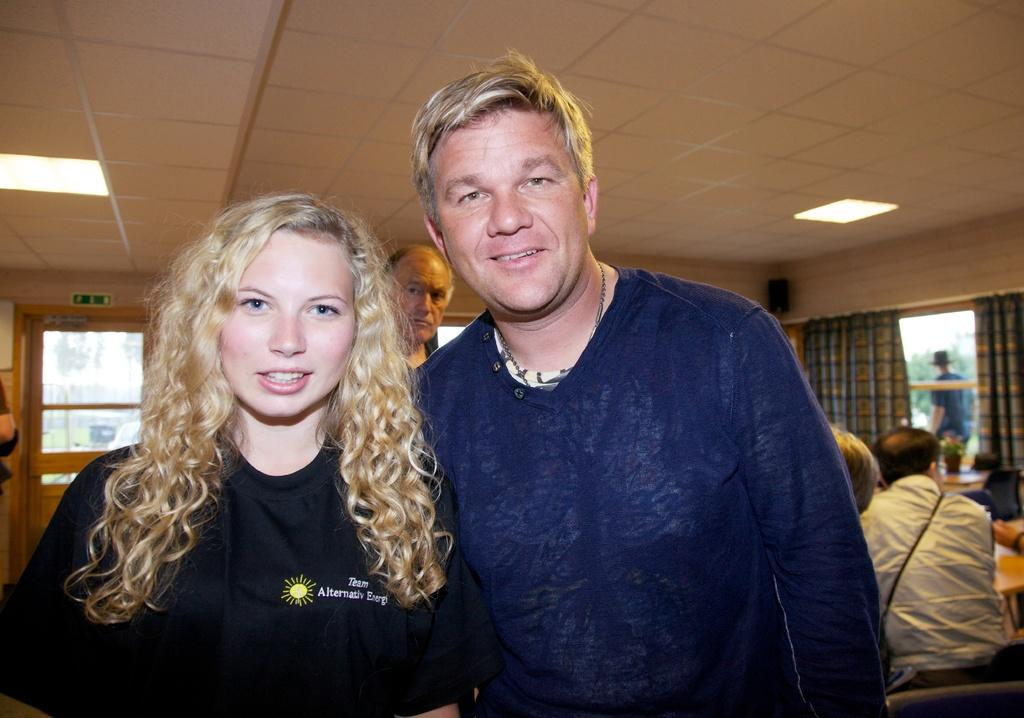How many people are in the image? There is a group of people in the image, but the exact number is not specified. What are the people in the image doing? Some people are seated, while others are standing. What can be seen in the background of the image? There are curtains, a speaker, lights, and trees in the background of the image. What type of guide is the farmer in the image? There is no guide or farmer present in the image. How does the taste of the lights affect the people in the image? The lights in the image do not have a taste, as they are not edible. 